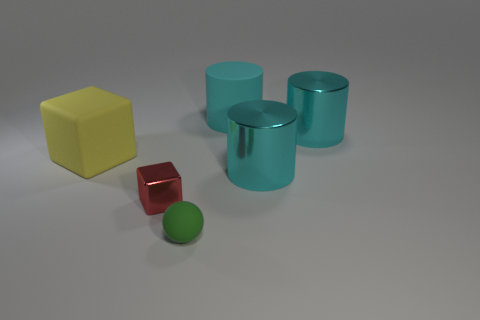Does the large thing in front of the large yellow object have the same color as the big rubber cylinder?
Offer a very short reply. Yes. There is a large rubber cylinder; is it the same color as the metallic cylinder in front of the big cube?
Give a very brief answer. Yes. There is a red metal object; are there any big yellow cubes behind it?
Provide a succinct answer. Yes. Is the material of the yellow thing the same as the tiny block?
Provide a succinct answer. No. There is a thing that is the same size as the matte sphere; what is its material?
Provide a succinct answer. Metal. How many objects are rubber things on the left side of the ball or brown objects?
Your response must be concise. 1. Is the number of yellow rubber things that are left of the tiny green rubber thing the same as the number of large things?
Provide a short and direct response. No. What color is the thing that is in front of the big cyan matte object and behind the yellow block?
Offer a terse response. Cyan. What number of cylinders are either tiny red metal objects or metal things?
Provide a short and direct response. 2. Is the number of metallic objects behind the yellow cube less than the number of metal cylinders?
Your answer should be compact. Yes. 